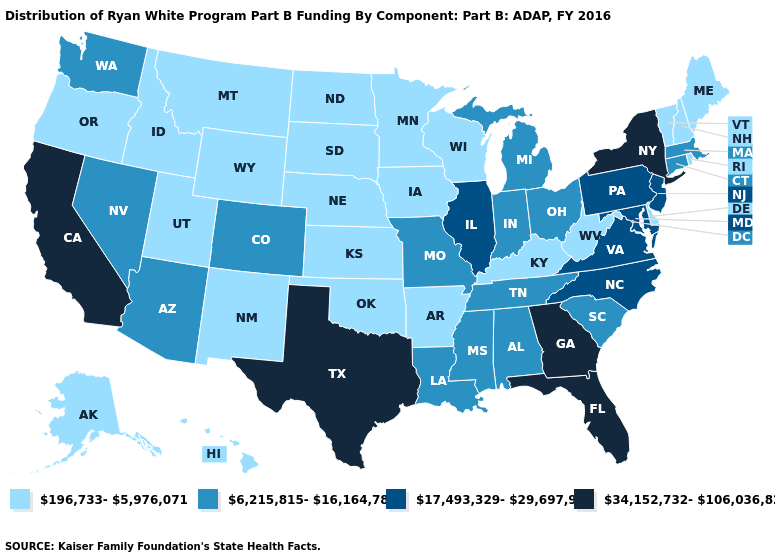Among the states that border Michigan , does Indiana have the highest value?
Write a very short answer. Yes. What is the value of Wyoming?
Write a very short answer. 196,733-5,976,071. Which states have the lowest value in the USA?
Be succinct. Alaska, Arkansas, Delaware, Hawaii, Idaho, Iowa, Kansas, Kentucky, Maine, Minnesota, Montana, Nebraska, New Hampshire, New Mexico, North Dakota, Oklahoma, Oregon, Rhode Island, South Dakota, Utah, Vermont, West Virginia, Wisconsin, Wyoming. What is the lowest value in the USA?
Keep it brief. 196,733-5,976,071. Is the legend a continuous bar?
Be succinct. No. Which states have the lowest value in the USA?
Write a very short answer. Alaska, Arkansas, Delaware, Hawaii, Idaho, Iowa, Kansas, Kentucky, Maine, Minnesota, Montana, Nebraska, New Hampshire, New Mexico, North Dakota, Oklahoma, Oregon, Rhode Island, South Dakota, Utah, Vermont, West Virginia, Wisconsin, Wyoming. What is the value of Louisiana?
Concise answer only. 6,215,815-16,164,782. Name the states that have a value in the range 34,152,732-106,036,829?
Keep it brief. California, Florida, Georgia, New York, Texas. What is the highest value in the MidWest ?
Be succinct. 17,493,329-29,697,958. Which states have the lowest value in the USA?
Quick response, please. Alaska, Arkansas, Delaware, Hawaii, Idaho, Iowa, Kansas, Kentucky, Maine, Minnesota, Montana, Nebraska, New Hampshire, New Mexico, North Dakota, Oklahoma, Oregon, Rhode Island, South Dakota, Utah, Vermont, West Virginia, Wisconsin, Wyoming. Among the states that border Ohio , which have the highest value?
Give a very brief answer. Pennsylvania. What is the value of Texas?
Keep it brief. 34,152,732-106,036,829. What is the value of New Hampshire?
Answer briefly. 196,733-5,976,071. What is the value of New Jersey?
Be succinct. 17,493,329-29,697,958. What is the value of Indiana?
Be succinct. 6,215,815-16,164,782. 